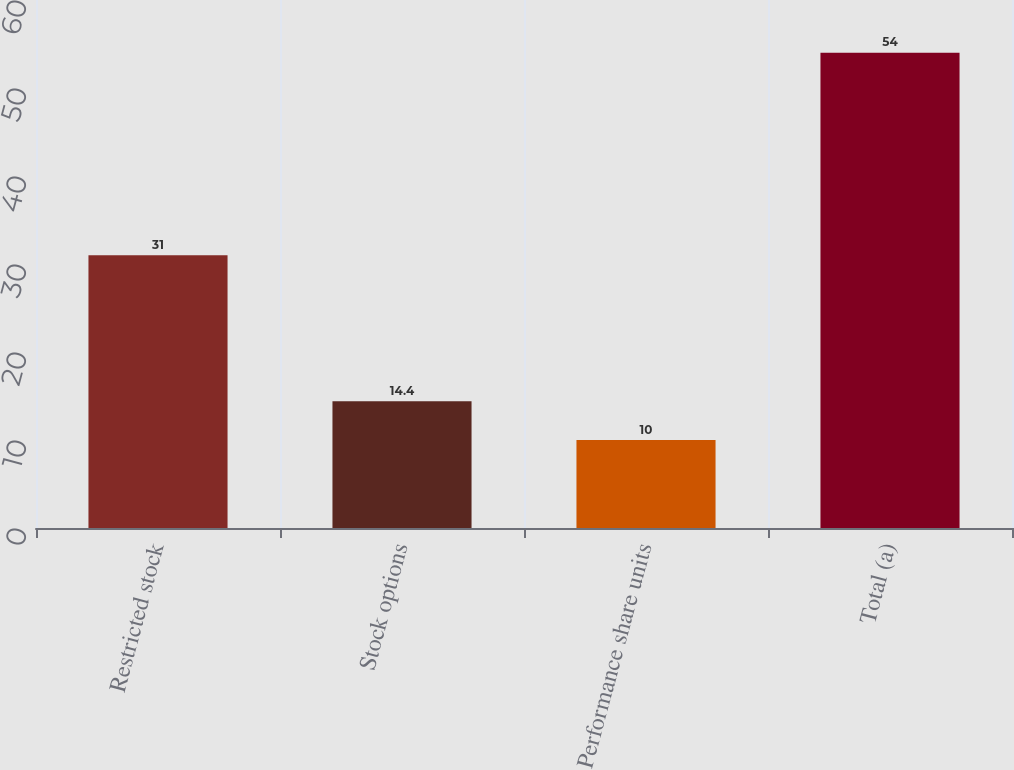Convert chart to OTSL. <chart><loc_0><loc_0><loc_500><loc_500><bar_chart><fcel>Restricted stock<fcel>Stock options<fcel>Performance share units<fcel>Total (a)<nl><fcel>31<fcel>14.4<fcel>10<fcel>54<nl></chart> 